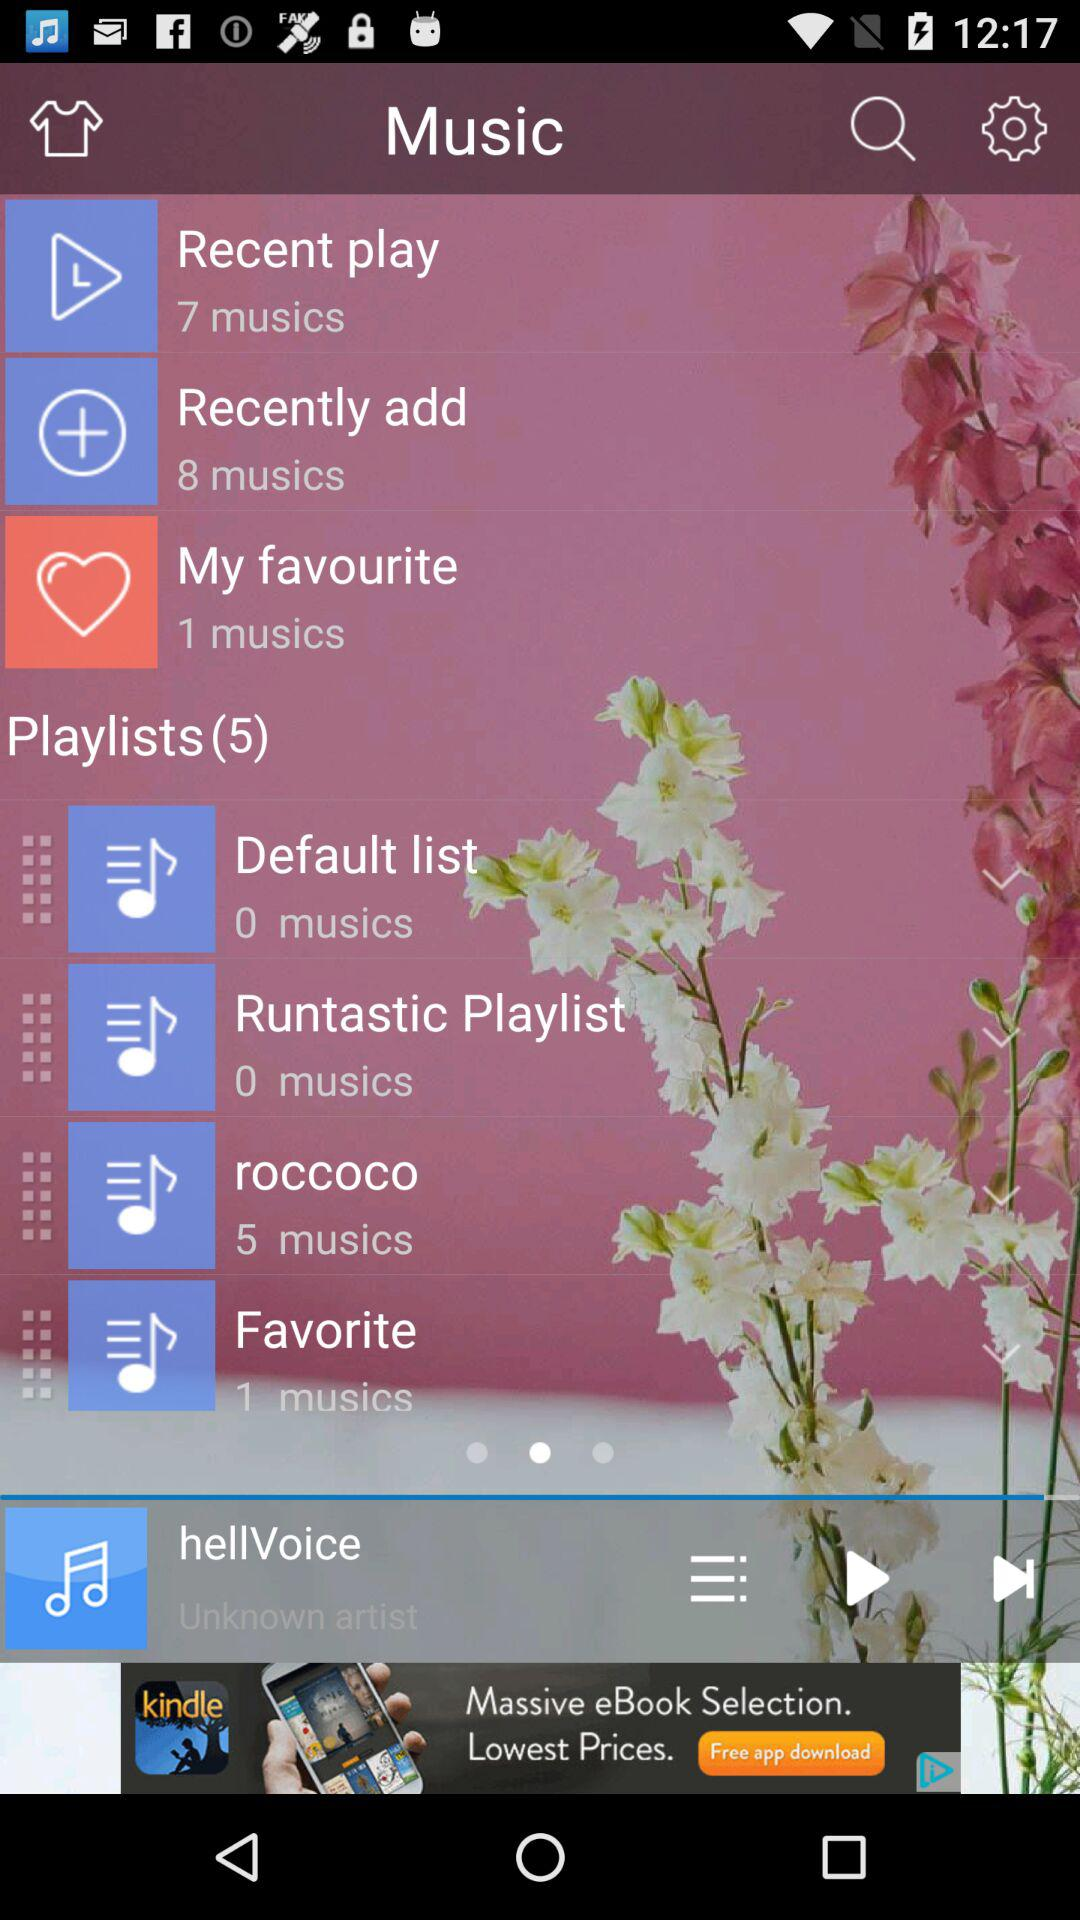How long is the track "hellVoice"?
When the provided information is insufficient, respond with <no answer>. <no answer> 